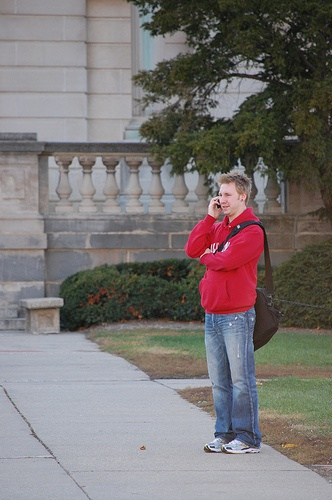Describe the objects in this image and their specific colors. I can see people in gray, brown, and darkgray tones, handbag in gray, black, and darkgreen tones, and cell phone in gray, black, darkgray, and maroon tones in this image. 